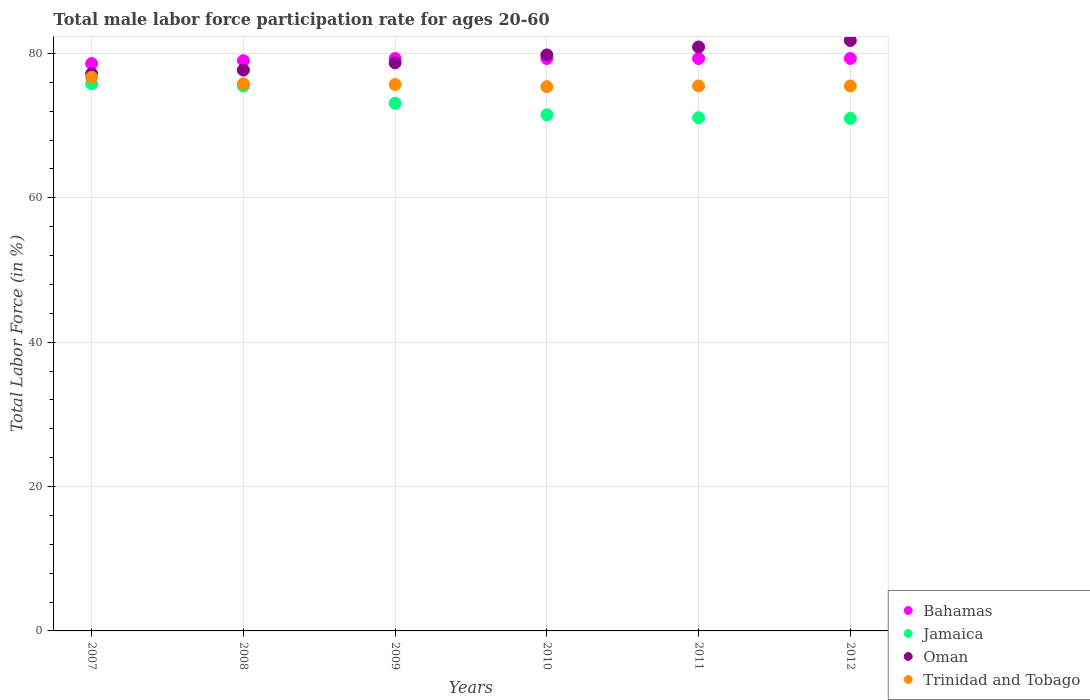Is the number of dotlines equal to the number of legend labels?
Provide a short and direct response. Yes. What is the male labor force participation rate in Trinidad and Tobago in 2008?
Give a very brief answer. 75.8. Across all years, what is the maximum male labor force participation rate in Trinidad and Tobago?
Make the answer very short. 76.7. In which year was the male labor force participation rate in Oman maximum?
Your answer should be compact. 2012. What is the total male labor force participation rate in Trinidad and Tobago in the graph?
Your response must be concise. 454.6. What is the difference between the male labor force participation rate in Trinidad and Tobago in 2011 and the male labor force participation rate in Bahamas in 2010?
Keep it short and to the point. -3.8. What is the average male labor force participation rate in Jamaica per year?
Your answer should be compact. 73. In the year 2010, what is the difference between the male labor force participation rate in Jamaica and male labor force participation rate in Bahamas?
Provide a succinct answer. -7.8. In how many years, is the male labor force participation rate in Jamaica greater than 64 %?
Your response must be concise. 6. What is the ratio of the male labor force participation rate in Jamaica in 2008 to that in 2012?
Your response must be concise. 1.06. Is the male labor force participation rate in Trinidad and Tobago in 2007 less than that in 2008?
Provide a short and direct response. No. What is the difference between the highest and the second highest male labor force participation rate in Oman?
Provide a short and direct response. 0.9. What is the difference between the highest and the lowest male labor force participation rate in Bahamas?
Provide a short and direct response. 0.7. In how many years, is the male labor force participation rate in Trinidad and Tobago greater than the average male labor force participation rate in Trinidad and Tobago taken over all years?
Provide a succinct answer. 2. Is it the case that in every year, the sum of the male labor force participation rate in Trinidad and Tobago and male labor force participation rate in Oman  is greater than the sum of male labor force participation rate in Bahamas and male labor force participation rate in Jamaica?
Your response must be concise. No. Is it the case that in every year, the sum of the male labor force participation rate in Oman and male labor force participation rate in Bahamas  is greater than the male labor force participation rate in Trinidad and Tobago?
Keep it short and to the point. Yes. How many dotlines are there?
Offer a terse response. 4. Does the graph contain any zero values?
Make the answer very short. No. Does the graph contain grids?
Provide a succinct answer. Yes. How are the legend labels stacked?
Your response must be concise. Vertical. What is the title of the graph?
Your answer should be very brief. Total male labor force participation rate for ages 20-60. Does "Upper middle income" appear as one of the legend labels in the graph?
Keep it short and to the point. No. What is the label or title of the X-axis?
Your response must be concise. Years. What is the label or title of the Y-axis?
Keep it short and to the point. Total Labor Force (in %). What is the Total Labor Force (in %) of Bahamas in 2007?
Provide a succinct answer. 78.6. What is the Total Labor Force (in %) of Jamaica in 2007?
Make the answer very short. 75.8. What is the Total Labor Force (in %) in Oman in 2007?
Provide a succinct answer. 77.2. What is the Total Labor Force (in %) of Trinidad and Tobago in 2007?
Ensure brevity in your answer.  76.7. What is the Total Labor Force (in %) in Bahamas in 2008?
Offer a terse response. 79. What is the Total Labor Force (in %) of Jamaica in 2008?
Your response must be concise. 75.5. What is the Total Labor Force (in %) of Oman in 2008?
Offer a terse response. 77.7. What is the Total Labor Force (in %) of Trinidad and Tobago in 2008?
Provide a succinct answer. 75.8. What is the Total Labor Force (in %) in Bahamas in 2009?
Your response must be concise. 79.3. What is the Total Labor Force (in %) in Jamaica in 2009?
Your answer should be compact. 73.1. What is the Total Labor Force (in %) in Oman in 2009?
Offer a terse response. 78.7. What is the Total Labor Force (in %) in Trinidad and Tobago in 2009?
Your answer should be very brief. 75.7. What is the Total Labor Force (in %) of Bahamas in 2010?
Provide a succinct answer. 79.3. What is the Total Labor Force (in %) in Jamaica in 2010?
Make the answer very short. 71.5. What is the Total Labor Force (in %) of Oman in 2010?
Offer a very short reply. 79.8. What is the Total Labor Force (in %) in Trinidad and Tobago in 2010?
Provide a succinct answer. 75.4. What is the Total Labor Force (in %) of Bahamas in 2011?
Your answer should be compact. 79.3. What is the Total Labor Force (in %) of Jamaica in 2011?
Your answer should be compact. 71.1. What is the Total Labor Force (in %) in Oman in 2011?
Offer a terse response. 80.9. What is the Total Labor Force (in %) of Trinidad and Tobago in 2011?
Offer a very short reply. 75.5. What is the Total Labor Force (in %) of Bahamas in 2012?
Provide a succinct answer. 79.3. What is the Total Labor Force (in %) in Oman in 2012?
Offer a terse response. 81.8. What is the Total Labor Force (in %) of Trinidad and Tobago in 2012?
Your response must be concise. 75.5. Across all years, what is the maximum Total Labor Force (in %) of Bahamas?
Your answer should be compact. 79.3. Across all years, what is the maximum Total Labor Force (in %) in Jamaica?
Make the answer very short. 75.8. Across all years, what is the maximum Total Labor Force (in %) in Oman?
Your response must be concise. 81.8. Across all years, what is the maximum Total Labor Force (in %) of Trinidad and Tobago?
Provide a succinct answer. 76.7. Across all years, what is the minimum Total Labor Force (in %) of Bahamas?
Provide a succinct answer. 78.6. Across all years, what is the minimum Total Labor Force (in %) of Oman?
Make the answer very short. 77.2. Across all years, what is the minimum Total Labor Force (in %) in Trinidad and Tobago?
Give a very brief answer. 75.4. What is the total Total Labor Force (in %) in Bahamas in the graph?
Your response must be concise. 474.8. What is the total Total Labor Force (in %) in Jamaica in the graph?
Provide a short and direct response. 438. What is the total Total Labor Force (in %) in Oman in the graph?
Offer a terse response. 476.1. What is the total Total Labor Force (in %) of Trinidad and Tobago in the graph?
Offer a very short reply. 454.6. What is the difference between the Total Labor Force (in %) in Bahamas in 2007 and that in 2008?
Your answer should be very brief. -0.4. What is the difference between the Total Labor Force (in %) of Jamaica in 2007 and that in 2008?
Your answer should be very brief. 0.3. What is the difference between the Total Labor Force (in %) in Oman in 2007 and that in 2008?
Provide a succinct answer. -0.5. What is the difference between the Total Labor Force (in %) in Trinidad and Tobago in 2007 and that in 2008?
Ensure brevity in your answer.  0.9. What is the difference between the Total Labor Force (in %) of Bahamas in 2007 and that in 2009?
Keep it short and to the point. -0.7. What is the difference between the Total Labor Force (in %) in Jamaica in 2007 and that in 2009?
Offer a terse response. 2.7. What is the difference between the Total Labor Force (in %) of Bahamas in 2007 and that in 2010?
Offer a very short reply. -0.7. What is the difference between the Total Labor Force (in %) of Oman in 2007 and that in 2010?
Your response must be concise. -2.6. What is the difference between the Total Labor Force (in %) of Trinidad and Tobago in 2007 and that in 2010?
Provide a succinct answer. 1.3. What is the difference between the Total Labor Force (in %) in Bahamas in 2007 and that in 2011?
Your answer should be compact. -0.7. What is the difference between the Total Labor Force (in %) in Oman in 2007 and that in 2011?
Ensure brevity in your answer.  -3.7. What is the difference between the Total Labor Force (in %) in Bahamas in 2008 and that in 2009?
Give a very brief answer. -0.3. What is the difference between the Total Labor Force (in %) in Oman in 2008 and that in 2009?
Offer a terse response. -1. What is the difference between the Total Labor Force (in %) in Trinidad and Tobago in 2008 and that in 2009?
Keep it short and to the point. 0.1. What is the difference between the Total Labor Force (in %) in Jamaica in 2008 and that in 2010?
Make the answer very short. 4. What is the difference between the Total Labor Force (in %) in Oman in 2008 and that in 2010?
Keep it short and to the point. -2.1. What is the difference between the Total Labor Force (in %) of Oman in 2008 and that in 2011?
Offer a very short reply. -3.2. What is the difference between the Total Labor Force (in %) of Jamaica in 2008 and that in 2012?
Give a very brief answer. 4.5. What is the difference between the Total Labor Force (in %) of Oman in 2008 and that in 2012?
Make the answer very short. -4.1. What is the difference between the Total Labor Force (in %) in Trinidad and Tobago in 2008 and that in 2012?
Provide a short and direct response. 0.3. What is the difference between the Total Labor Force (in %) in Bahamas in 2009 and that in 2010?
Your answer should be compact. 0. What is the difference between the Total Labor Force (in %) of Jamaica in 2009 and that in 2010?
Your answer should be compact. 1.6. What is the difference between the Total Labor Force (in %) of Oman in 2009 and that in 2010?
Provide a succinct answer. -1.1. What is the difference between the Total Labor Force (in %) of Trinidad and Tobago in 2009 and that in 2010?
Ensure brevity in your answer.  0.3. What is the difference between the Total Labor Force (in %) in Bahamas in 2009 and that in 2011?
Offer a very short reply. 0. What is the difference between the Total Labor Force (in %) of Jamaica in 2009 and that in 2011?
Make the answer very short. 2. What is the difference between the Total Labor Force (in %) of Trinidad and Tobago in 2009 and that in 2011?
Keep it short and to the point. 0.2. What is the difference between the Total Labor Force (in %) of Bahamas in 2009 and that in 2012?
Your answer should be compact. 0. What is the difference between the Total Labor Force (in %) of Jamaica in 2009 and that in 2012?
Your response must be concise. 2.1. What is the difference between the Total Labor Force (in %) of Oman in 2009 and that in 2012?
Your answer should be very brief. -3.1. What is the difference between the Total Labor Force (in %) in Trinidad and Tobago in 2009 and that in 2012?
Offer a very short reply. 0.2. What is the difference between the Total Labor Force (in %) of Bahamas in 2010 and that in 2011?
Provide a succinct answer. 0. What is the difference between the Total Labor Force (in %) in Jamaica in 2010 and that in 2011?
Make the answer very short. 0.4. What is the difference between the Total Labor Force (in %) of Jamaica in 2010 and that in 2012?
Keep it short and to the point. 0.5. What is the difference between the Total Labor Force (in %) in Oman in 2010 and that in 2012?
Offer a very short reply. -2. What is the difference between the Total Labor Force (in %) of Trinidad and Tobago in 2010 and that in 2012?
Offer a terse response. -0.1. What is the difference between the Total Labor Force (in %) in Bahamas in 2007 and the Total Labor Force (in %) in Jamaica in 2008?
Offer a very short reply. 3.1. What is the difference between the Total Labor Force (in %) in Bahamas in 2007 and the Total Labor Force (in %) in Oman in 2008?
Keep it short and to the point. 0.9. What is the difference between the Total Labor Force (in %) of Bahamas in 2007 and the Total Labor Force (in %) of Trinidad and Tobago in 2008?
Provide a succinct answer. 2.8. What is the difference between the Total Labor Force (in %) in Jamaica in 2007 and the Total Labor Force (in %) in Trinidad and Tobago in 2008?
Provide a short and direct response. 0. What is the difference between the Total Labor Force (in %) of Bahamas in 2007 and the Total Labor Force (in %) of Jamaica in 2009?
Make the answer very short. 5.5. What is the difference between the Total Labor Force (in %) of Bahamas in 2007 and the Total Labor Force (in %) of Oman in 2009?
Keep it short and to the point. -0.1. What is the difference between the Total Labor Force (in %) in Bahamas in 2007 and the Total Labor Force (in %) in Trinidad and Tobago in 2009?
Offer a terse response. 2.9. What is the difference between the Total Labor Force (in %) of Jamaica in 2007 and the Total Labor Force (in %) of Trinidad and Tobago in 2009?
Provide a short and direct response. 0.1. What is the difference between the Total Labor Force (in %) of Bahamas in 2007 and the Total Labor Force (in %) of Jamaica in 2010?
Your answer should be very brief. 7.1. What is the difference between the Total Labor Force (in %) in Bahamas in 2007 and the Total Labor Force (in %) in Oman in 2010?
Keep it short and to the point. -1.2. What is the difference between the Total Labor Force (in %) in Bahamas in 2007 and the Total Labor Force (in %) in Trinidad and Tobago in 2010?
Give a very brief answer. 3.2. What is the difference between the Total Labor Force (in %) in Bahamas in 2007 and the Total Labor Force (in %) in Jamaica in 2011?
Your answer should be compact. 7.5. What is the difference between the Total Labor Force (in %) of Bahamas in 2007 and the Total Labor Force (in %) of Jamaica in 2012?
Ensure brevity in your answer.  7.6. What is the difference between the Total Labor Force (in %) in Jamaica in 2007 and the Total Labor Force (in %) in Oman in 2012?
Your answer should be very brief. -6. What is the difference between the Total Labor Force (in %) of Bahamas in 2008 and the Total Labor Force (in %) of Jamaica in 2009?
Offer a terse response. 5.9. What is the difference between the Total Labor Force (in %) in Bahamas in 2008 and the Total Labor Force (in %) in Oman in 2009?
Offer a terse response. 0.3. What is the difference between the Total Labor Force (in %) of Bahamas in 2008 and the Total Labor Force (in %) of Trinidad and Tobago in 2009?
Provide a short and direct response. 3.3. What is the difference between the Total Labor Force (in %) of Jamaica in 2008 and the Total Labor Force (in %) of Oman in 2009?
Give a very brief answer. -3.2. What is the difference between the Total Labor Force (in %) of Jamaica in 2008 and the Total Labor Force (in %) of Trinidad and Tobago in 2009?
Provide a short and direct response. -0.2. What is the difference between the Total Labor Force (in %) of Oman in 2008 and the Total Labor Force (in %) of Trinidad and Tobago in 2009?
Ensure brevity in your answer.  2. What is the difference between the Total Labor Force (in %) in Bahamas in 2008 and the Total Labor Force (in %) in Jamaica in 2010?
Provide a succinct answer. 7.5. What is the difference between the Total Labor Force (in %) in Bahamas in 2008 and the Total Labor Force (in %) in Oman in 2010?
Give a very brief answer. -0.8. What is the difference between the Total Labor Force (in %) in Jamaica in 2008 and the Total Labor Force (in %) in Oman in 2010?
Ensure brevity in your answer.  -4.3. What is the difference between the Total Labor Force (in %) of Jamaica in 2008 and the Total Labor Force (in %) of Trinidad and Tobago in 2010?
Give a very brief answer. 0.1. What is the difference between the Total Labor Force (in %) of Bahamas in 2008 and the Total Labor Force (in %) of Trinidad and Tobago in 2011?
Give a very brief answer. 3.5. What is the difference between the Total Labor Force (in %) of Jamaica in 2008 and the Total Labor Force (in %) of Oman in 2011?
Make the answer very short. -5.4. What is the difference between the Total Labor Force (in %) in Jamaica in 2008 and the Total Labor Force (in %) in Trinidad and Tobago in 2011?
Offer a very short reply. 0. What is the difference between the Total Labor Force (in %) of Bahamas in 2008 and the Total Labor Force (in %) of Jamaica in 2012?
Your answer should be very brief. 8. What is the difference between the Total Labor Force (in %) of Bahamas in 2008 and the Total Labor Force (in %) of Trinidad and Tobago in 2012?
Offer a very short reply. 3.5. What is the difference between the Total Labor Force (in %) of Oman in 2008 and the Total Labor Force (in %) of Trinidad and Tobago in 2012?
Your answer should be compact. 2.2. What is the difference between the Total Labor Force (in %) in Jamaica in 2009 and the Total Labor Force (in %) in Oman in 2010?
Offer a very short reply. -6.7. What is the difference between the Total Labor Force (in %) of Bahamas in 2009 and the Total Labor Force (in %) of Jamaica in 2011?
Provide a succinct answer. 8.2. What is the difference between the Total Labor Force (in %) in Bahamas in 2009 and the Total Labor Force (in %) in Oman in 2011?
Your answer should be compact. -1.6. What is the difference between the Total Labor Force (in %) of Oman in 2009 and the Total Labor Force (in %) of Trinidad and Tobago in 2011?
Your answer should be very brief. 3.2. What is the difference between the Total Labor Force (in %) in Bahamas in 2009 and the Total Labor Force (in %) in Jamaica in 2012?
Your answer should be compact. 8.3. What is the difference between the Total Labor Force (in %) of Bahamas in 2009 and the Total Labor Force (in %) of Trinidad and Tobago in 2012?
Ensure brevity in your answer.  3.8. What is the difference between the Total Labor Force (in %) in Jamaica in 2009 and the Total Labor Force (in %) in Oman in 2012?
Offer a terse response. -8.7. What is the difference between the Total Labor Force (in %) in Bahamas in 2010 and the Total Labor Force (in %) in Oman in 2011?
Keep it short and to the point. -1.6. What is the difference between the Total Labor Force (in %) in Oman in 2010 and the Total Labor Force (in %) in Trinidad and Tobago in 2011?
Provide a short and direct response. 4.3. What is the difference between the Total Labor Force (in %) of Bahamas in 2010 and the Total Labor Force (in %) of Oman in 2012?
Your answer should be compact. -2.5. What is the difference between the Total Labor Force (in %) in Jamaica in 2010 and the Total Labor Force (in %) in Oman in 2012?
Keep it short and to the point. -10.3. What is the difference between the Total Labor Force (in %) of Bahamas in 2011 and the Total Labor Force (in %) of Jamaica in 2012?
Your answer should be very brief. 8.3. What is the difference between the Total Labor Force (in %) of Bahamas in 2011 and the Total Labor Force (in %) of Trinidad and Tobago in 2012?
Make the answer very short. 3.8. What is the difference between the Total Labor Force (in %) of Jamaica in 2011 and the Total Labor Force (in %) of Oman in 2012?
Provide a short and direct response. -10.7. What is the difference between the Total Labor Force (in %) of Oman in 2011 and the Total Labor Force (in %) of Trinidad and Tobago in 2012?
Your response must be concise. 5.4. What is the average Total Labor Force (in %) of Bahamas per year?
Offer a very short reply. 79.13. What is the average Total Labor Force (in %) in Oman per year?
Provide a short and direct response. 79.35. What is the average Total Labor Force (in %) in Trinidad and Tobago per year?
Offer a terse response. 75.77. In the year 2007, what is the difference between the Total Labor Force (in %) in Bahamas and Total Labor Force (in %) in Oman?
Give a very brief answer. 1.4. In the year 2007, what is the difference between the Total Labor Force (in %) in Bahamas and Total Labor Force (in %) in Trinidad and Tobago?
Your answer should be compact. 1.9. In the year 2007, what is the difference between the Total Labor Force (in %) in Oman and Total Labor Force (in %) in Trinidad and Tobago?
Ensure brevity in your answer.  0.5. In the year 2008, what is the difference between the Total Labor Force (in %) in Bahamas and Total Labor Force (in %) in Jamaica?
Give a very brief answer. 3.5. In the year 2008, what is the difference between the Total Labor Force (in %) in Bahamas and Total Labor Force (in %) in Oman?
Your answer should be very brief. 1.3. In the year 2008, what is the difference between the Total Labor Force (in %) of Oman and Total Labor Force (in %) of Trinidad and Tobago?
Make the answer very short. 1.9. In the year 2009, what is the difference between the Total Labor Force (in %) of Bahamas and Total Labor Force (in %) of Jamaica?
Your answer should be very brief. 6.2. In the year 2009, what is the difference between the Total Labor Force (in %) of Bahamas and Total Labor Force (in %) of Trinidad and Tobago?
Offer a very short reply. 3.6. In the year 2010, what is the difference between the Total Labor Force (in %) in Bahamas and Total Labor Force (in %) in Oman?
Offer a terse response. -0.5. In the year 2010, what is the difference between the Total Labor Force (in %) in Jamaica and Total Labor Force (in %) in Trinidad and Tobago?
Offer a terse response. -3.9. In the year 2010, what is the difference between the Total Labor Force (in %) of Oman and Total Labor Force (in %) of Trinidad and Tobago?
Ensure brevity in your answer.  4.4. In the year 2011, what is the difference between the Total Labor Force (in %) of Bahamas and Total Labor Force (in %) of Trinidad and Tobago?
Give a very brief answer. 3.8. In the year 2011, what is the difference between the Total Labor Force (in %) of Jamaica and Total Labor Force (in %) of Oman?
Your answer should be very brief. -9.8. In the year 2011, what is the difference between the Total Labor Force (in %) in Oman and Total Labor Force (in %) in Trinidad and Tobago?
Provide a succinct answer. 5.4. In the year 2012, what is the difference between the Total Labor Force (in %) of Bahamas and Total Labor Force (in %) of Jamaica?
Provide a succinct answer. 8.3. In the year 2012, what is the difference between the Total Labor Force (in %) in Bahamas and Total Labor Force (in %) in Oman?
Ensure brevity in your answer.  -2.5. In the year 2012, what is the difference between the Total Labor Force (in %) in Bahamas and Total Labor Force (in %) in Trinidad and Tobago?
Offer a terse response. 3.8. In the year 2012, what is the difference between the Total Labor Force (in %) of Jamaica and Total Labor Force (in %) of Oman?
Provide a succinct answer. -10.8. In the year 2012, what is the difference between the Total Labor Force (in %) of Jamaica and Total Labor Force (in %) of Trinidad and Tobago?
Offer a terse response. -4.5. In the year 2012, what is the difference between the Total Labor Force (in %) in Oman and Total Labor Force (in %) in Trinidad and Tobago?
Offer a terse response. 6.3. What is the ratio of the Total Labor Force (in %) in Bahamas in 2007 to that in 2008?
Provide a succinct answer. 0.99. What is the ratio of the Total Labor Force (in %) in Oman in 2007 to that in 2008?
Your answer should be compact. 0.99. What is the ratio of the Total Labor Force (in %) in Trinidad and Tobago in 2007 to that in 2008?
Ensure brevity in your answer.  1.01. What is the ratio of the Total Labor Force (in %) in Bahamas in 2007 to that in 2009?
Provide a short and direct response. 0.99. What is the ratio of the Total Labor Force (in %) of Jamaica in 2007 to that in 2009?
Offer a terse response. 1.04. What is the ratio of the Total Labor Force (in %) of Oman in 2007 to that in 2009?
Offer a very short reply. 0.98. What is the ratio of the Total Labor Force (in %) in Trinidad and Tobago in 2007 to that in 2009?
Your answer should be very brief. 1.01. What is the ratio of the Total Labor Force (in %) of Jamaica in 2007 to that in 2010?
Your answer should be very brief. 1.06. What is the ratio of the Total Labor Force (in %) of Oman in 2007 to that in 2010?
Make the answer very short. 0.97. What is the ratio of the Total Labor Force (in %) of Trinidad and Tobago in 2007 to that in 2010?
Provide a succinct answer. 1.02. What is the ratio of the Total Labor Force (in %) in Bahamas in 2007 to that in 2011?
Your answer should be compact. 0.99. What is the ratio of the Total Labor Force (in %) in Jamaica in 2007 to that in 2011?
Provide a short and direct response. 1.07. What is the ratio of the Total Labor Force (in %) in Oman in 2007 to that in 2011?
Your answer should be compact. 0.95. What is the ratio of the Total Labor Force (in %) in Trinidad and Tobago in 2007 to that in 2011?
Provide a short and direct response. 1.02. What is the ratio of the Total Labor Force (in %) in Jamaica in 2007 to that in 2012?
Give a very brief answer. 1.07. What is the ratio of the Total Labor Force (in %) in Oman in 2007 to that in 2012?
Your answer should be very brief. 0.94. What is the ratio of the Total Labor Force (in %) in Trinidad and Tobago in 2007 to that in 2012?
Your answer should be compact. 1.02. What is the ratio of the Total Labor Force (in %) of Bahamas in 2008 to that in 2009?
Ensure brevity in your answer.  1. What is the ratio of the Total Labor Force (in %) of Jamaica in 2008 to that in 2009?
Offer a terse response. 1.03. What is the ratio of the Total Labor Force (in %) of Oman in 2008 to that in 2009?
Offer a very short reply. 0.99. What is the ratio of the Total Labor Force (in %) in Bahamas in 2008 to that in 2010?
Keep it short and to the point. 1. What is the ratio of the Total Labor Force (in %) of Jamaica in 2008 to that in 2010?
Offer a very short reply. 1.06. What is the ratio of the Total Labor Force (in %) of Oman in 2008 to that in 2010?
Provide a short and direct response. 0.97. What is the ratio of the Total Labor Force (in %) of Bahamas in 2008 to that in 2011?
Offer a very short reply. 1. What is the ratio of the Total Labor Force (in %) of Jamaica in 2008 to that in 2011?
Your answer should be very brief. 1.06. What is the ratio of the Total Labor Force (in %) of Oman in 2008 to that in 2011?
Provide a short and direct response. 0.96. What is the ratio of the Total Labor Force (in %) in Trinidad and Tobago in 2008 to that in 2011?
Your response must be concise. 1. What is the ratio of the Total Labor Force (in %) of Bahamas in 2008 to that in 2012?
Keep it short and to the point. 1. What is the ratio of the Total Labor Force (in %) of Jamaica in 2008 to that in 2012?
Give a very brief answer. 1.06. What is the ratio of the Total Labor Force (in %) in Oman in 2008 to that in 2012?
Your response must be concise. 0.95. What is the ratio of the Total Labor Force (in %) of Bahamas in 2009 to that in 2010?
Offer a terse response. 1. What is the ratio of the Total Labor Force (in %) of Jamaica in 2009 to that in 2010?
Provide a short and direct response. 1.02. What is the ratio of the Total Labor Force (in %) of Oman in 2009 to that in 2010?
Ensure brevity in your answer.  0.99. What is the ratio of the Total Labor Force (in %) of Trinidad and Tobago in 2009 to that in 2010?
Provide a succinct answer. 1. What is the ratio of the Total Labor Force (in %) of Bahamas in 2009 to that in 2011?
Your answer should be very brief. 1. What is the ratio of the Total Labor Force (in %) in Jamaica in 2009 to that in 2011?
Provide a short and direct response. 1.03. What is the ratio of the Total Labor Force (in %) of Oman in 2009 to that in 2011?
Give a very brief answer. 0.97. What is the ratio of the Total Labor Force (in %) of Trinidad and Tobago in 2009 to that in 2011?
Keep it short and to the point. 1. What is the ratio of the Total Labor Force (in %) in Bahamas in 2009 to that in 2012?
Your response must be concise. 1. What is the ratio of the Total Labor Force (in %) of Jamaica in 2009 to that in 2012?
Keep it short and to the point. 1.03. What is the ratio of the Total Labor Force (in %) of Oman in 2009 to that in 2012?
Offer a very short reply. 0.96. What is the ratio of the Total Labor Force (in %) in Bahamas in 2010 to that in 2011?
Give a very brief answer. 1. What is the ratio of the Total Labor Force (in %) of Jamaica in 2010 to that in 2011?
Offer a very short reply. 1.01. What is the ratio of the Total Labor Force (in %) in Oman in 2010 to that in 2011?
Your answer should be compact. 0.99. What is the ratio of the Total Labor Force (in %) of Trinidad and Tobago in 2010 to that in 2011?
Keep it short and to the point. 1. What is the ratio of the Total Labor Force (in %) in Jamaica in 2010 to that in 2012?
Keep it short and to the point. 1.01. What is the ratio of the Total Labor Force (in %) in Oman in 2010 to that in 2012?
Give a very brief answer. 0.98. What is the ratio of the Total Labor Force (in %) of Bahamas in 2011 to that in 2012?
Offer a very short reply. 1. What is the ratio of the Total Labor Force (in %) of Jamaica in 2011 to that in 2012?
Keep it short and to the point. 1. What is the ratio of the Total Labor Force (in %) in Oman in 2011 to that in 2012?
Make the answer very short. 0.99. What is the ratio of the Total Labor Force (in %) in Trinidad and Tobago in 2011 to that in 2012?
Offer a very short reply. 1. What is the difference between the highest and the second highest Total Labor Force (in %) in Bahamas?
Your answer should be compact. 0. What is the difference between the highest and the second highest Total Labor Force (in %) in Oman?
Keep it short and to the point. 0.9. What is the difference between the highest and the lowest Total Labor Force (in %) of Bahamas?
Offer a terse response. 0.7. What is the difference between the highest and the lowest Total Labor Force (in %) in Oman?
Provide a succinct answer. 4.6. What is the difference between the highest and the lowest Total Labor Force (in %) in Trinidad and Tobago?
Give a very brief answer. 1.3. 